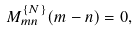Convert formula to latex. <formula><loc_0><loc_0><loc_500><loc_500>M ^ { \{ N \} } _ { m n } ( m - n ) = 0 ,</formula> 